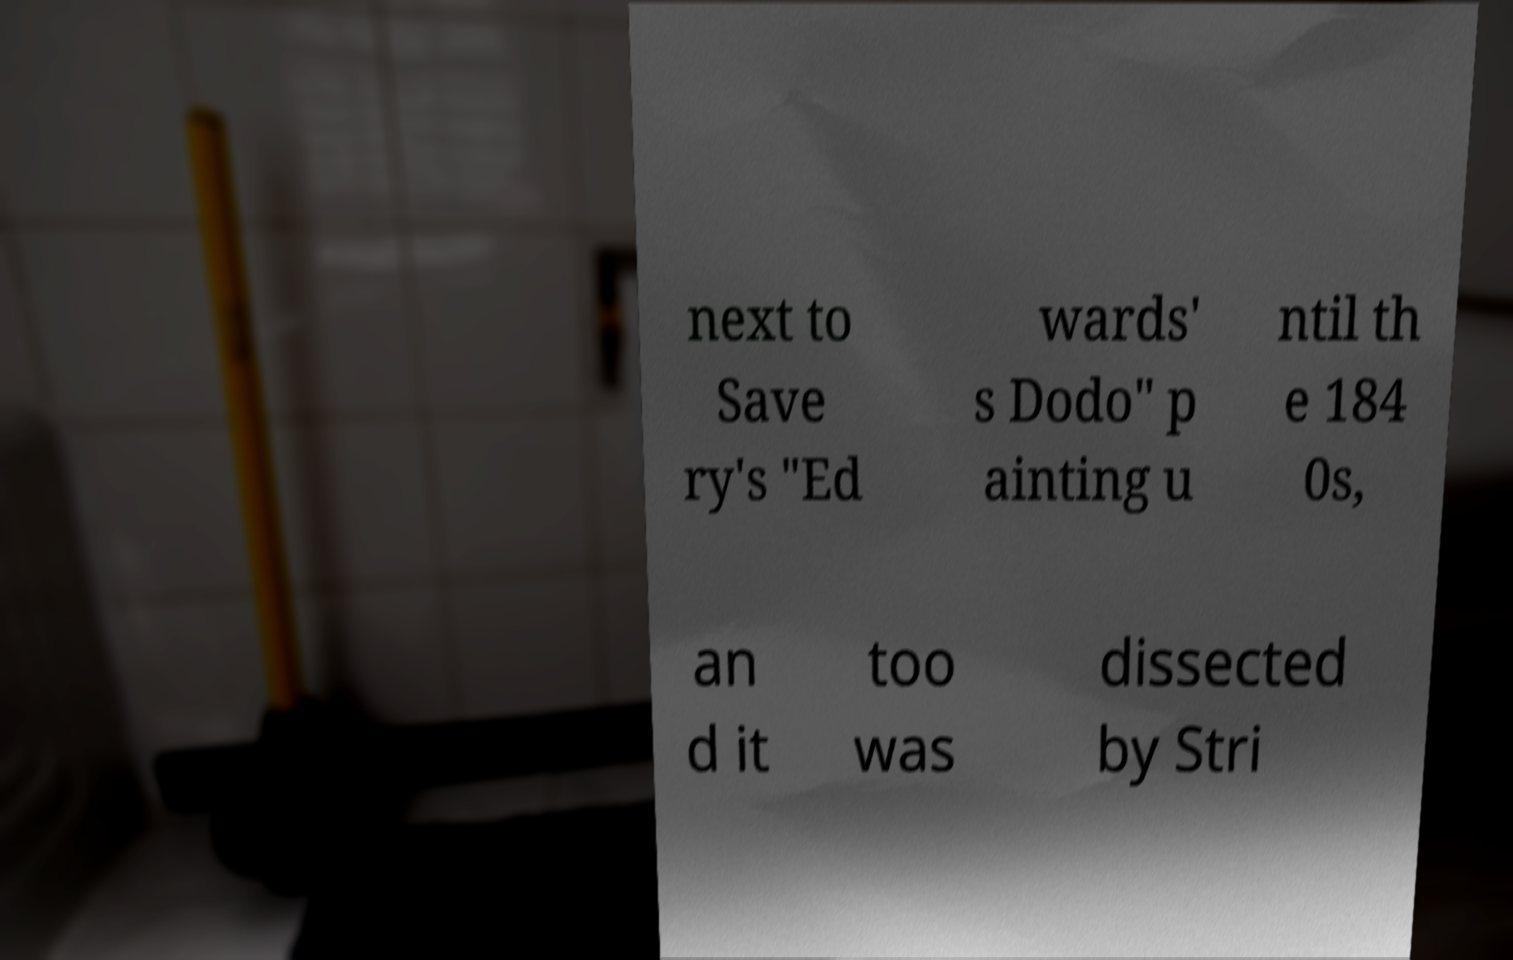Can you accurately transcribe the text from the provided image for me? next to Save ry's "Ed wards' s Dodo" p ainting u ntil th e 184 0s, an d it too was dissected by Stri 